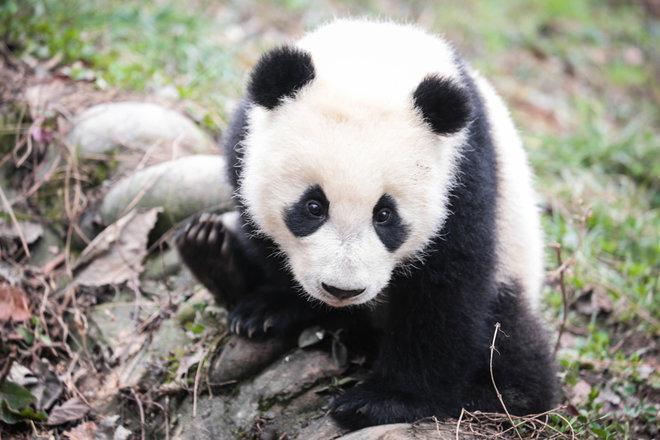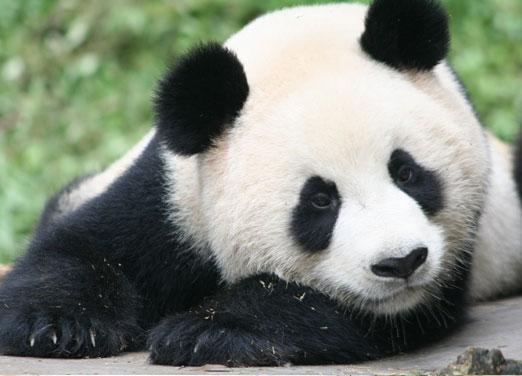The first image is the image on the left, the second image is the image on the right. For the images shown, is this caption "A panda is eating bamboo." true? Answer yes or no. No. The first image is the image on the left, the second image is the image on the right. Examine the images to the left and right. Is the description "Panda in the right image is nibbling something." accurate? Answer yes or no. No. 